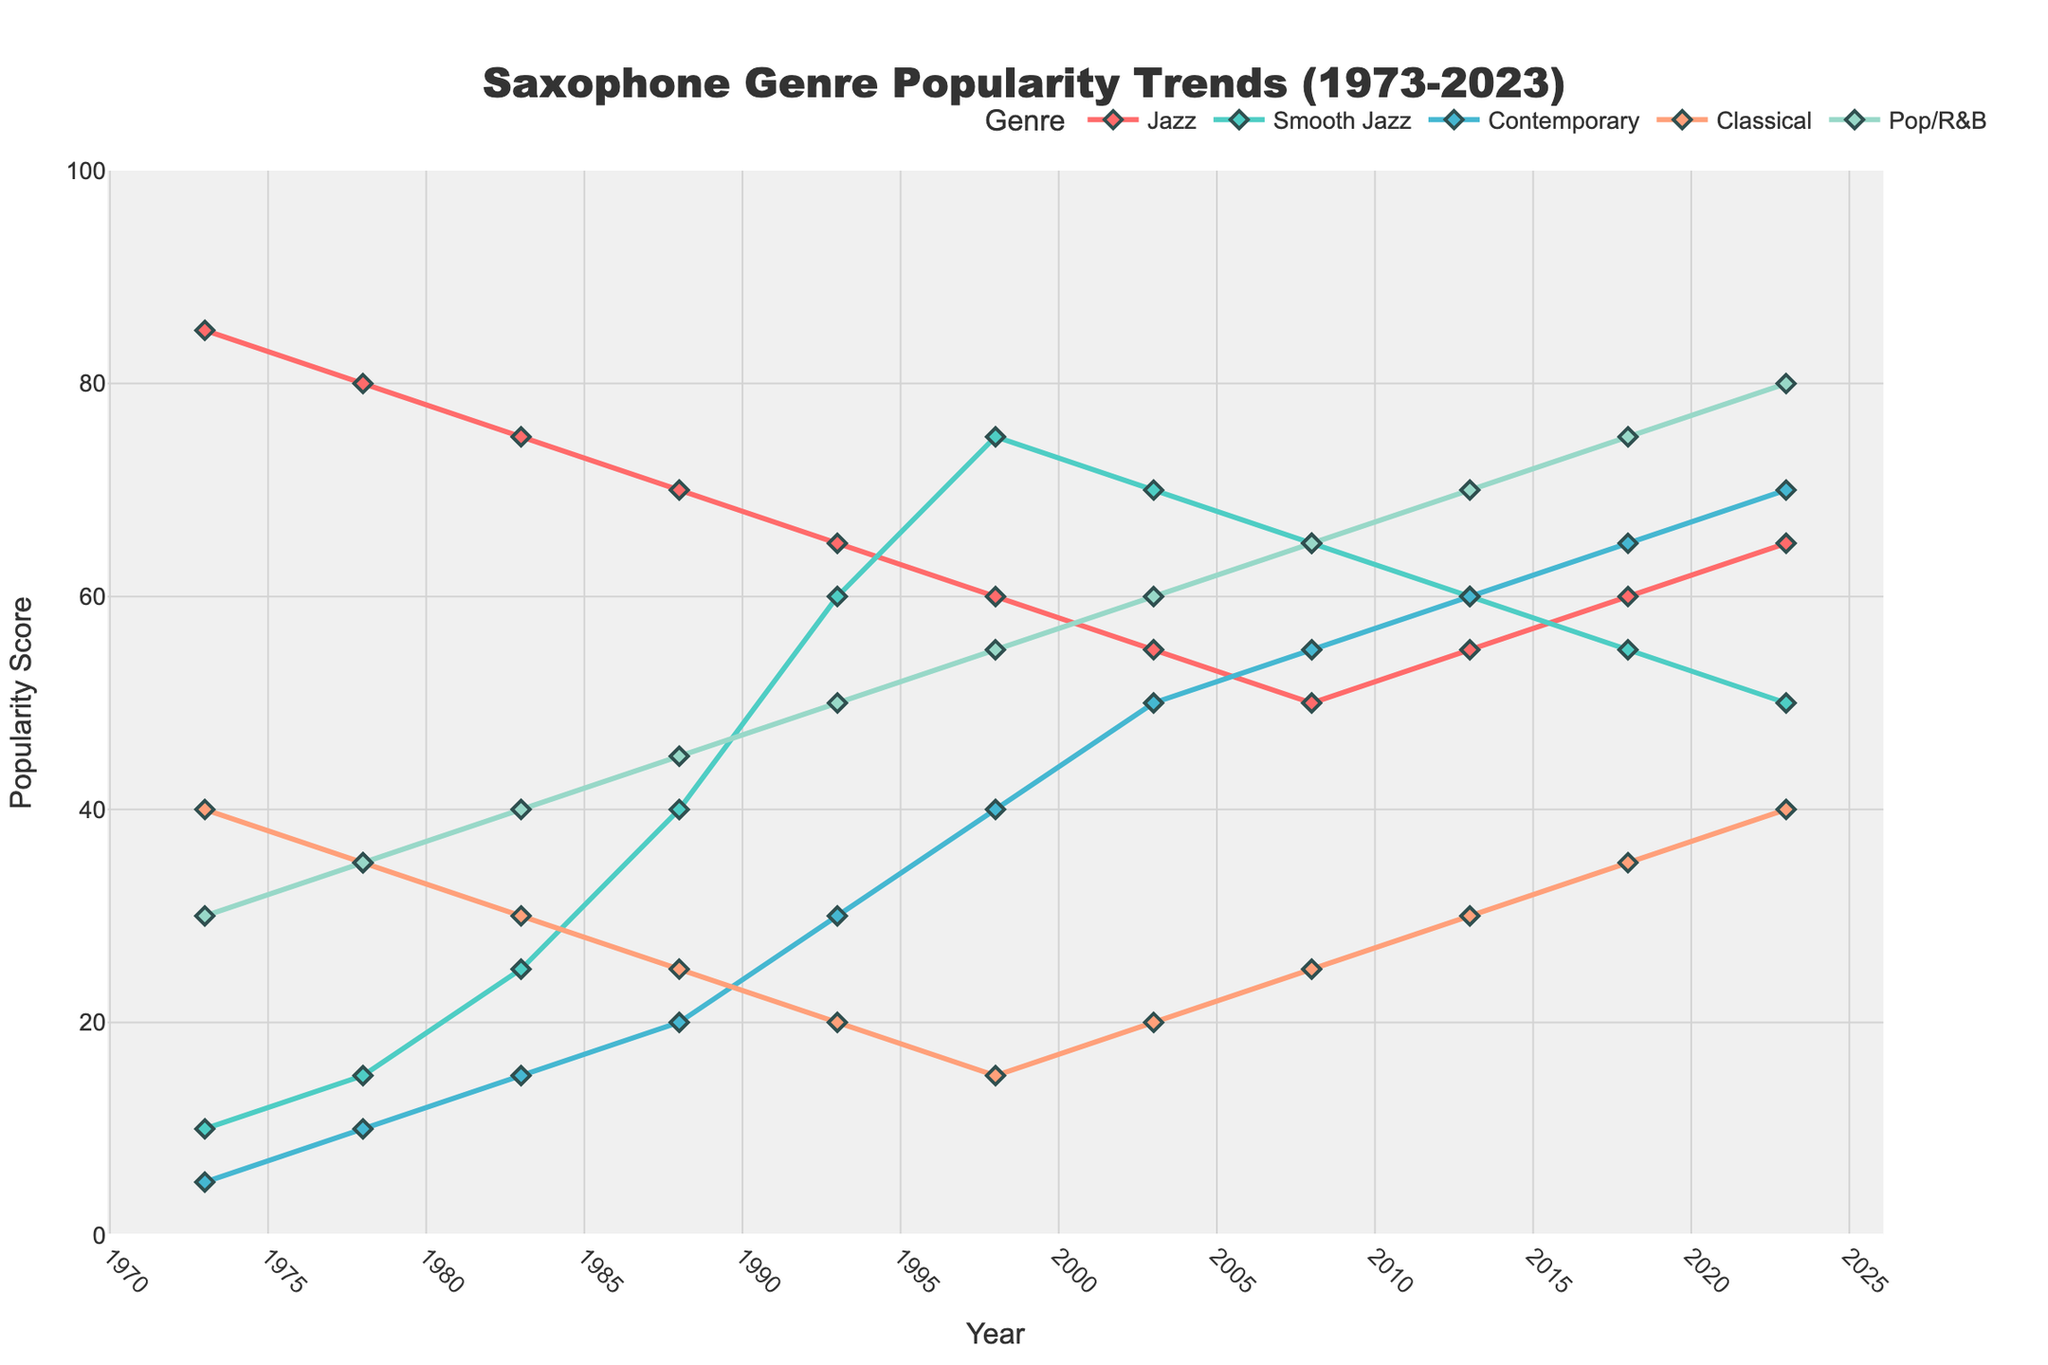What genre had the highest popularity score in 2023? Look at the popularity scores for each genre in 2023. Pop/R&B has a score of 80, which is the highest among all genres for that year.
Answer: Pop/R&B Which genre's popularity increased the most between 1973 and 2023? Calculate the difference in popularity scores for each genre between 1973 and 2023. Smooth Jazz's popularity increased from 10 in 1973 to 50 in 2023, an increase of 40 points, which is the highest.
Answer: Smooth Jazz During which decade did Classical's popularity score decline the fastest? Compare the popularity scores of Classical for each decade. The steepest decline occurred between 1973 and 1983, dropping from 40 to 30 (a decrease of 10 points).
Answer: 1973-1983 At what year did Contemporary surpass Classical in popularity for the first time? Track the popularity scores across the years. Contemporary surpasses Classical in 2003 (Contemporary: 50 vs Classical: 20).
Answer: 2003 Order the genres by their popularity score in 1988. List the popularity scores for each genre in 1988 and arrange them in descending order: Pop/R&B (45), Smooth Jazz (40), Jazz (70), Contemporary (20), Classical (25).
Answer: Jazz, Smooth Jazz, Pop/R&B, Classical, Contemporary What is the average popularity score of Jazz over the 50-year period? Add all the popularity scores of Jazz from 1973 to 2023 and divide by the number of data points: (85+80+75+70+65+60+55+50+55+60+65) / 11 = 64.55
Answer: 64.55 How does the trend in Pop/R&B's popularity between 1973 and 2023 compare to Jazz? Pop/R&B's popularity increases consistently from 1973 to 2023, ending at 80. Jazz shows a decreasing trend, starting at 85 in 1973 and ending at 65 in 2023.
Answer: Pop/R&B increased, Jazz decreased By how much did Smooth Jazz's popularity change between 1973 and 1983? Subtract Smooth Jazz's popularity in 1973 from its popularity in 1983: 25 - 10 = 15 points.
Answer: Increased by 15 What is the difference in popularity scores between Smooth Jazz and Jazz in 1993? Look at the scores for 1993: Smooth Jazz (60) and Jazz (65). The difference is 65 - 60 = 5 points.
Answer: 5 Which genre had the highest popularity increase from 2008 to 2013? Compare all genres' popularity scores from 2008 to 2013. Contemporary increased from 55 to 60, which is a 5-point increase, the highest among all genres.
Answer: Contemporary 